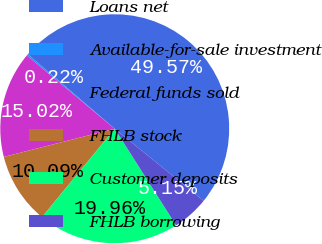Convert chart. <chart><loc_0><loc_0><loc_500><loc_500><pie_chart><fcel>Loans net<fcel>Available-for-sale investment<fcel>Federal funds sold<fcel>FHLB stock<fcel>Customer deposits<fcel>FHLB borrowing<nl><fcel>49.57%<fcel>0.22%<fcel>15.02%<fcel>10.09%<fcel>19.96%<fcel>5.15%<nl></chart> 